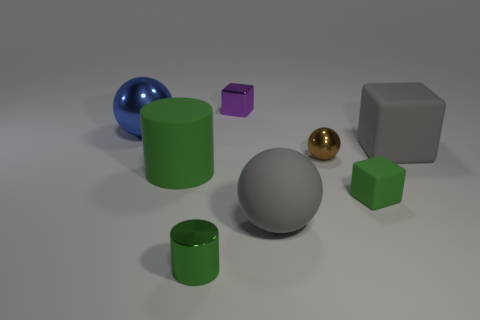There is a block that is the same color as the shiny cylinder; what is its material?
Make the answer very short. Rubber. How many other things are there of the same color as the tiny rubber block?
Your response must be concise. 2. What is the shape of the tiny thing that is in front of the big block and left of the large rubber ball?
Ensure brevity in your answer.  Cylinder. Are there more big spheres than purple metallic spheres?
Offer a terse response. Yes. What is the material of the large gray cube?
Offer a very short reply. Rubber. Are there any other things that have the same size as the blue shiny thing?
Keep it short and to the point. Yes. What size is the green matte object that is the same shape as the tiny purple metal object?
Provide a short and direct response. Small. There is a purple metallic block behind the large matte cube; is there a small brown shiny thing to the left of it?
Ensure brevity in your answer.  No. Is the small cylinder the same color as the large metallic sphere?
Provide a short and direct response. No. How many other things are there of the same shape as the green shiny object?
Keep it short and to the point. 1. 